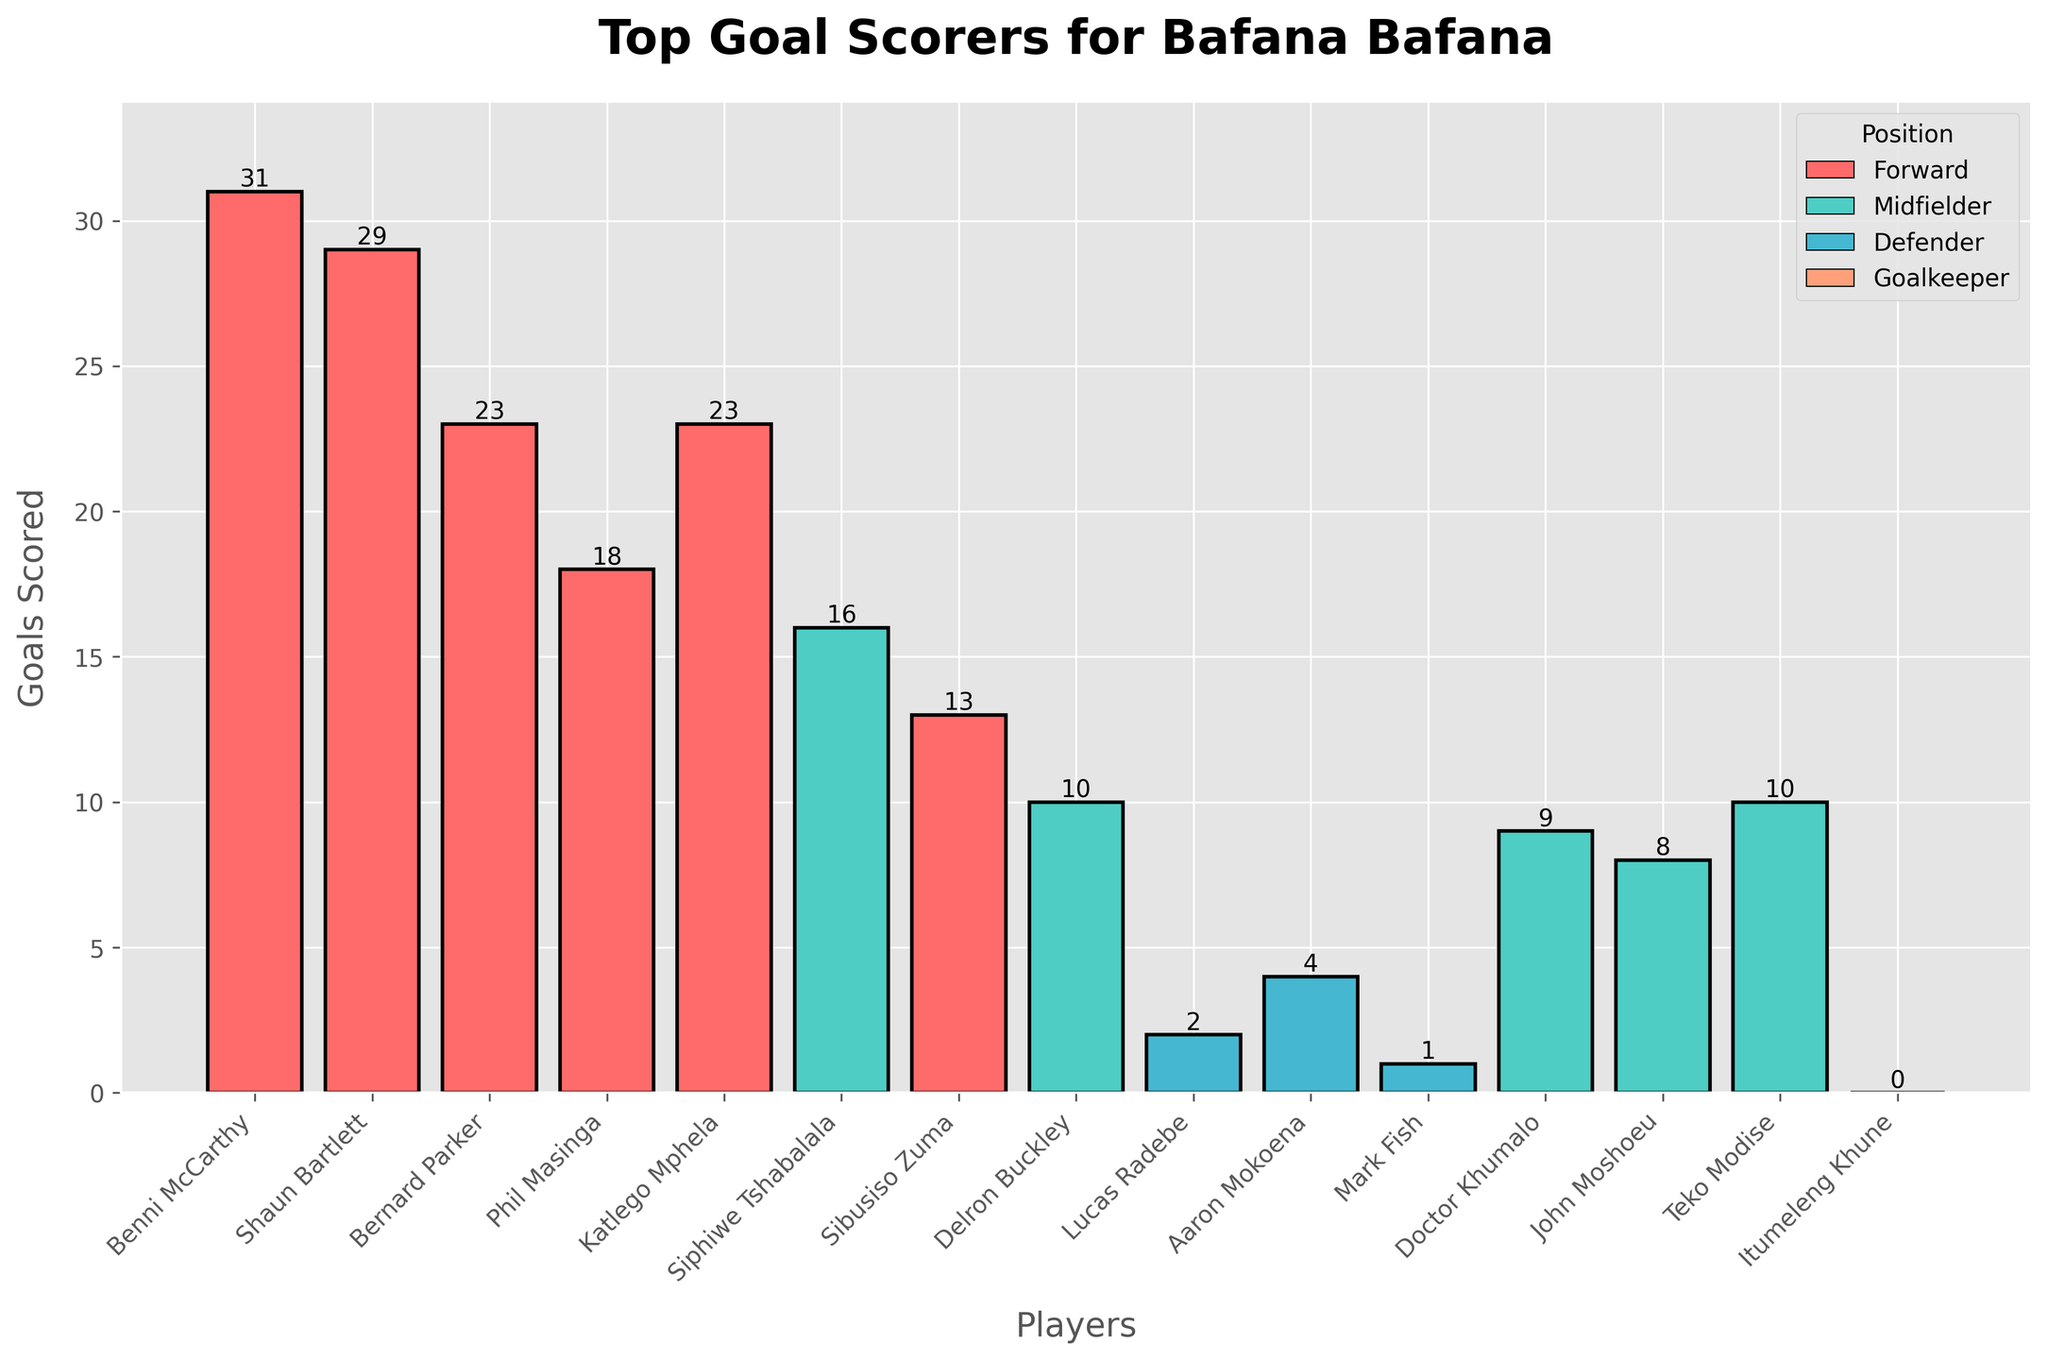Which player has scored the most goals? Look at the player's bar with the highest value. Benni McCarthy's bar is the tallest, indicating he has scored the most goals.
Answer: Benni McCarthy Which position has the majority of top goal scorers? Examine the colors of the bars and identify which position color appears most frequently. The red bars represent the 'Forward' position, and they dominate the chart.
Answer: Forward How many goals have been scored by midfielders in total? Add the number of goals from all players listed as midfielders or midfielder/forward. These are Siphiwe Tshabalala (16), Delron Buckley (10), Doctor Khumalo (9), John Moshoeu (8), Teko Modise (10), and Bernard Parker (23). The sum is 76
Answer: 76 What's the difference in goals between the highest and the lowest scorers? Identify the player with the most goals (Benni McCarthy with 31) and the player with the least goals (Itumeleng Khune with 0). Subtract the least from the most (31 - 0).
Answer: 31 Who are the top three goal-scorers, and what positions do they play? Identify the three highest bars in the chart. They belong to Benni McCarthy (Forward), Shaun Bartlett (Forward), and Bernard Parker (Forward/Midfielder).
Answer: Benni McCarthy (Forward), Shaun Bartlett (Forward), Bernard Parker (Forward/Midfielder) What is the average number of goals scored by defenders? Sum the goals scored by Lucas Radebe (2), Aaron Mokoena (4), and Mark Fish (1). The sum is 7. There are 3 defenders, so divide 7 by 3 to get the average (7/3 ≈ 2.33).
Answer: 2.33 How many players have scored more than 20 goals? Identify the bars that extend beyond the 20-goal mark. The players are Benni McCarthy, Shaun Bartlett, Bernard Parker, and Katlego Mphela, totaling 4 players.
Answer: 4 Which player has scored the least goals among midfielders? Identify the shortest bar among the midfielders. Doctor Khumalo, John Moshoeu, Delron Buckley, Siphiwe Tshabalala, Teko Modise, and Bernard Parker are midfielders. John Moshoeu has the shortest bar with 8 goals.
Answer: John Moshoeu Compare the goals scored by Shaun Bartlett and Katlego Mphela. How many more goals has Shaun Bartlett scored? Shaun Bartlett has scored 29 goals, and Katlego Mphela has scored 23. Subtract 23 from 29 (29 - 23).
Answer: 6 